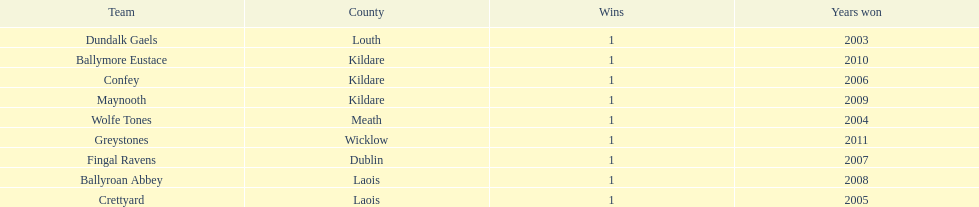What is the last team on the chart Dundalk Gaels. 